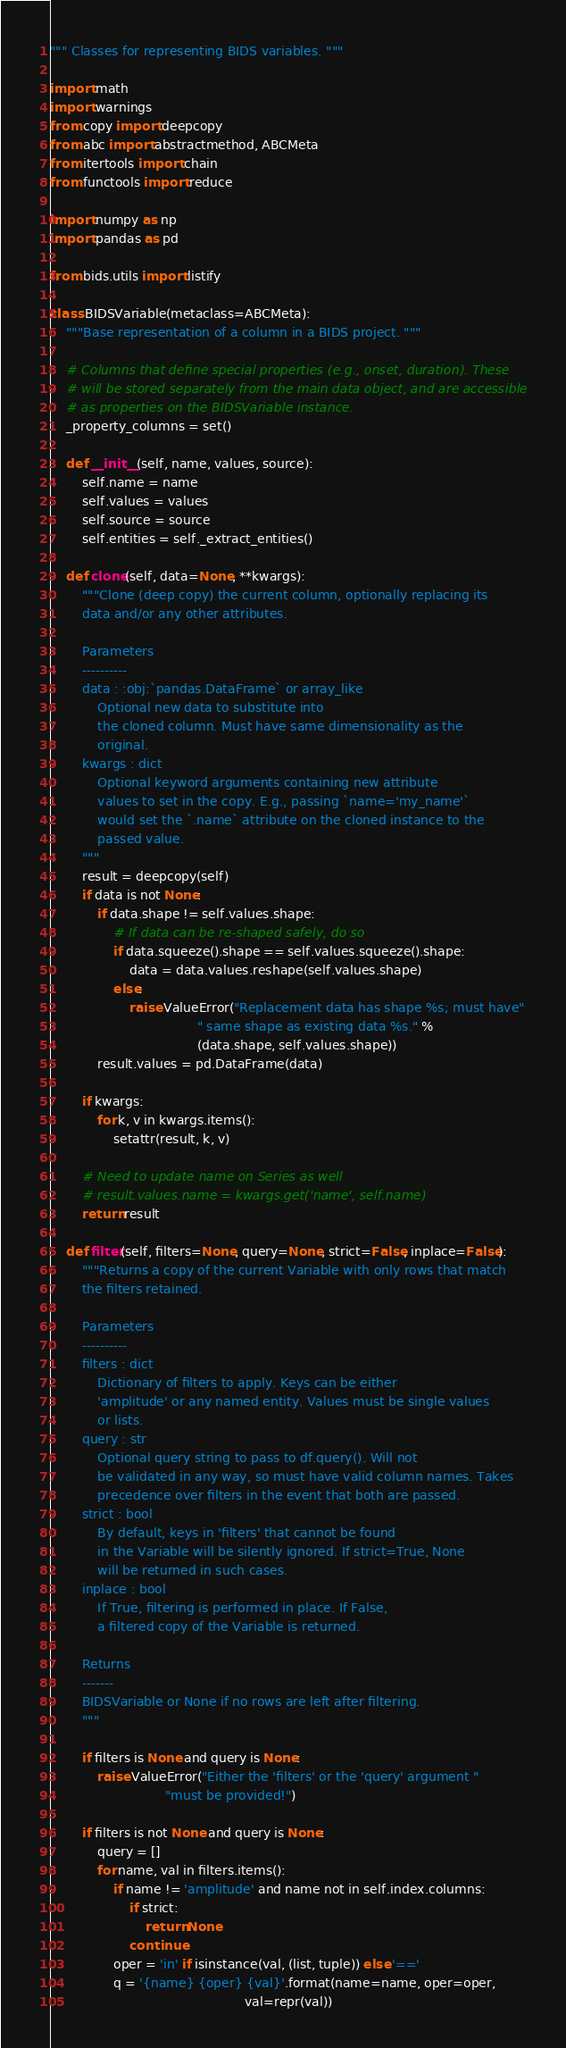<code> <loc_0><loc_0><loc_500><loc_500><_Python_>""" Classes for representing BIDS variables. """

import math
import warnings
from copy import deepcopy
from abc import abstractmethod, ABCMeta
from itertools import chain
from functools import reduce

import numpy as np
import pandas as pd

from bids.utils import listify

class BIDSVariable(metaclass=ABCMeta):
    """Base representation of a column in a BIDS project. """

    # Columns that define special properties (e.g., onset, duration). These
    # will be stored separately from the main data object, and are accessible
    # as properties on the BIDSVariable instance.
    _property_columns = set()

    def __init__(self, name, values, source):
        self.name = name
        self.values = values
        self.source = source
        self.entities = self._extract_entities()

    def clone(self, data=None, **kwargs):
        """Clone (deep copy) the current column, optionally replacing its
        data and/or any other attributes.

        Parameters
        ----------
        data : :obj:`pandas.DataFrame` or array_like
            Optional new data to substitute into
            the cloned column. Must have same dimensionality as the
            original.
        kwargs : dict
            Optional keyword arguments containing new attribute
            values to set in the copy. E.g., passing `name='my_name'`
            would set the `.name` attribute on the cloned instance to the
            passed value.
        """
        result = deepcopy(self)
        if data is not None:
            if data.shape != self.values.shape:
                # If data can be re-shaped safely, do so
                if data.squeeze().shape == self.values.squeeze().shape:
                    data = data.values.reshape(self.values.shape)
                else:
                    raise ValueError("Replacement data has shape %s; must have"
                                     " same shape as existing data %s." %
                                     (data.shape, self.values.shape))
            result.values = pd.DataFrame(data)

        if kwargs:
            for k, v in kwargs.items():
                setattr(result, k, v)

        # Need to update name on Series as well
        # result.values.name = kwargs.get('name', self.name)
        return result

    def filter(self, filters=None, query=None, strict=False, inplace=False):
        """Returns a copy of the current Variable with only rows that match
        the filters retained.

        Parameters
        ----------
        filters : dict
            Dictionary of filters to apply. Keys can be either
            'amplitude' or any named entity. Values must be single values
            or lists.
        query : str
            Optional query string to pass to df.query(). Will not
            be validated in any way, so must have valid column names. Takes
            precedence over filters in the event that both are passed.
        strict : bool
            By default, keys in 'filters' that cannot be found
            in the Variable will be silently ignored. If strict=True, None
            will be returned in such cases.
        inplace : bool
            If True, filtering is performed in place. If False,
            a filtered copy of the Variable is returned.

        Returns
        -------
        BIDSVariable or None if no rows are left after filtering.
        """

        if filters is None and query is None:
            raise ValueError("Either the 'filters' or the 'query' argument "
                             "must be provided!")

        if filters is not None and query is None:
            query = []
            for name, val in filters.items():
                if name != 'amplitude' and name not in self.index.columns:
                    if strict:
                        return None
                    continue
                oper = 'in' if isinstance(val, (list, tuple)) else '=='
                q = '{name} {oper} {val}'.format(name=name, oper=oper,
                                                 val=repr(val))</code> 